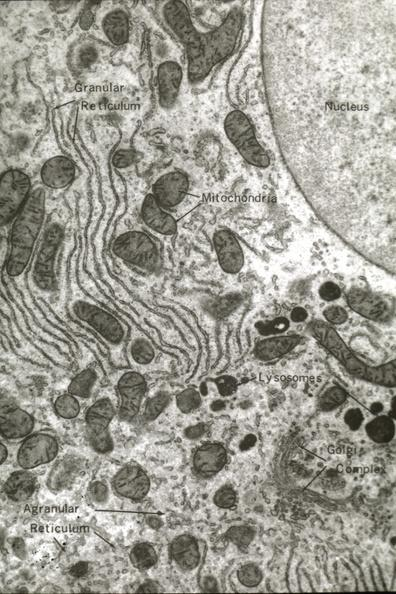what is present?
Answer the question using a single word or phrase. Liver 